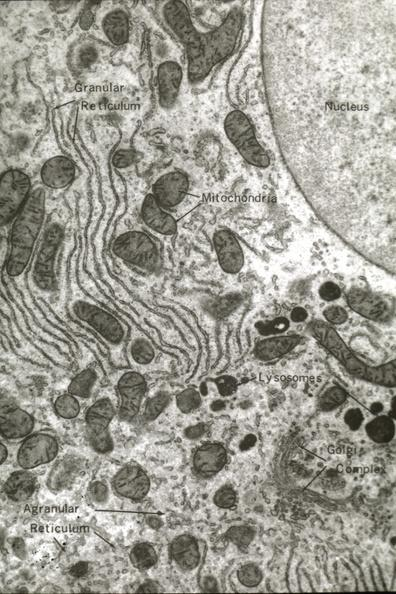what is present?
Answer the question using a single word or phrase. Liver 